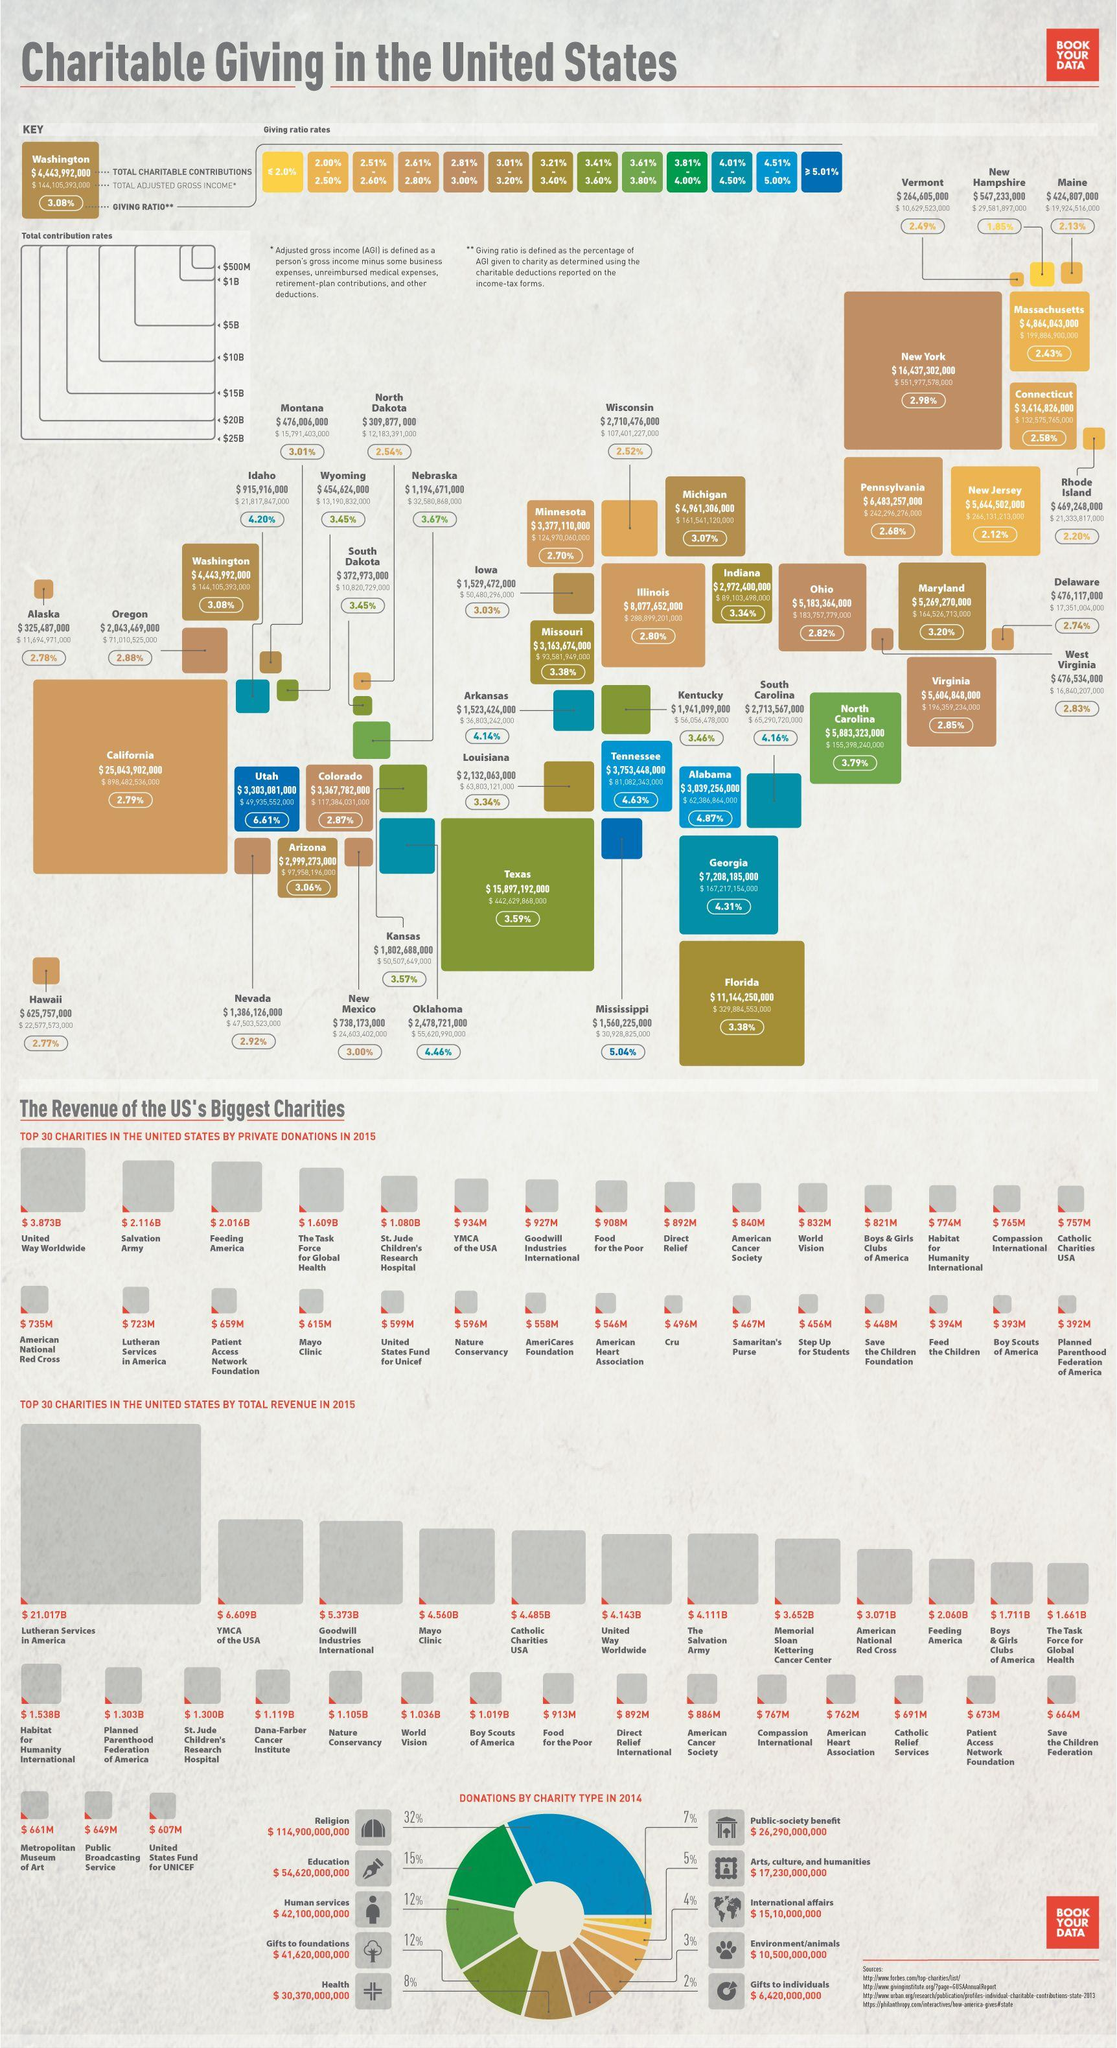Mention a couple of crucial points in this snapshot. In 2015, the second highest total revenue of charity organizations was $6.609 billion. In the state of New Hampshire, a total of $547,233,000 was contributed to charitable causes in the year 2022. The Public Broadcasting Service had the second lowest total revenue among all charity organizations in 2015. The total amount of public donations from society is $26,290,000,000. The total amount of charitable contributions from the state of Vermont was $264,605,000. 